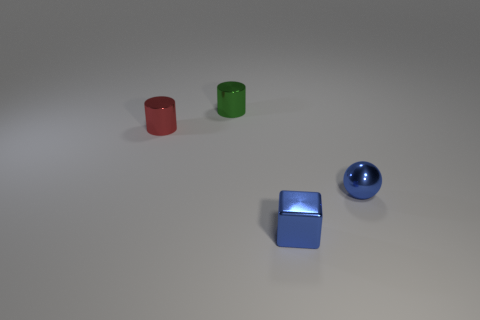Add 3 small balls. How many objects exist? 7 Subtract 2 cylinders. How many cylinders are left? 0 Subtract all balls. How many objects are left? 3 Subtract 0 brown blocks. How many objects are left? 4 Subtract all purple balls. Subtract all blue cylinders. How many balls are left? 1 Subtract all purple spheres. How many green cylinders are left? 1 Subtract all red cylinders. Subtract all tiny purple cylinders. How many objects are left? 3 Add 1 blue objects. How many blue objects are left? 3 Add 2 shiny cubes. How many shiny cubes exist? 3 